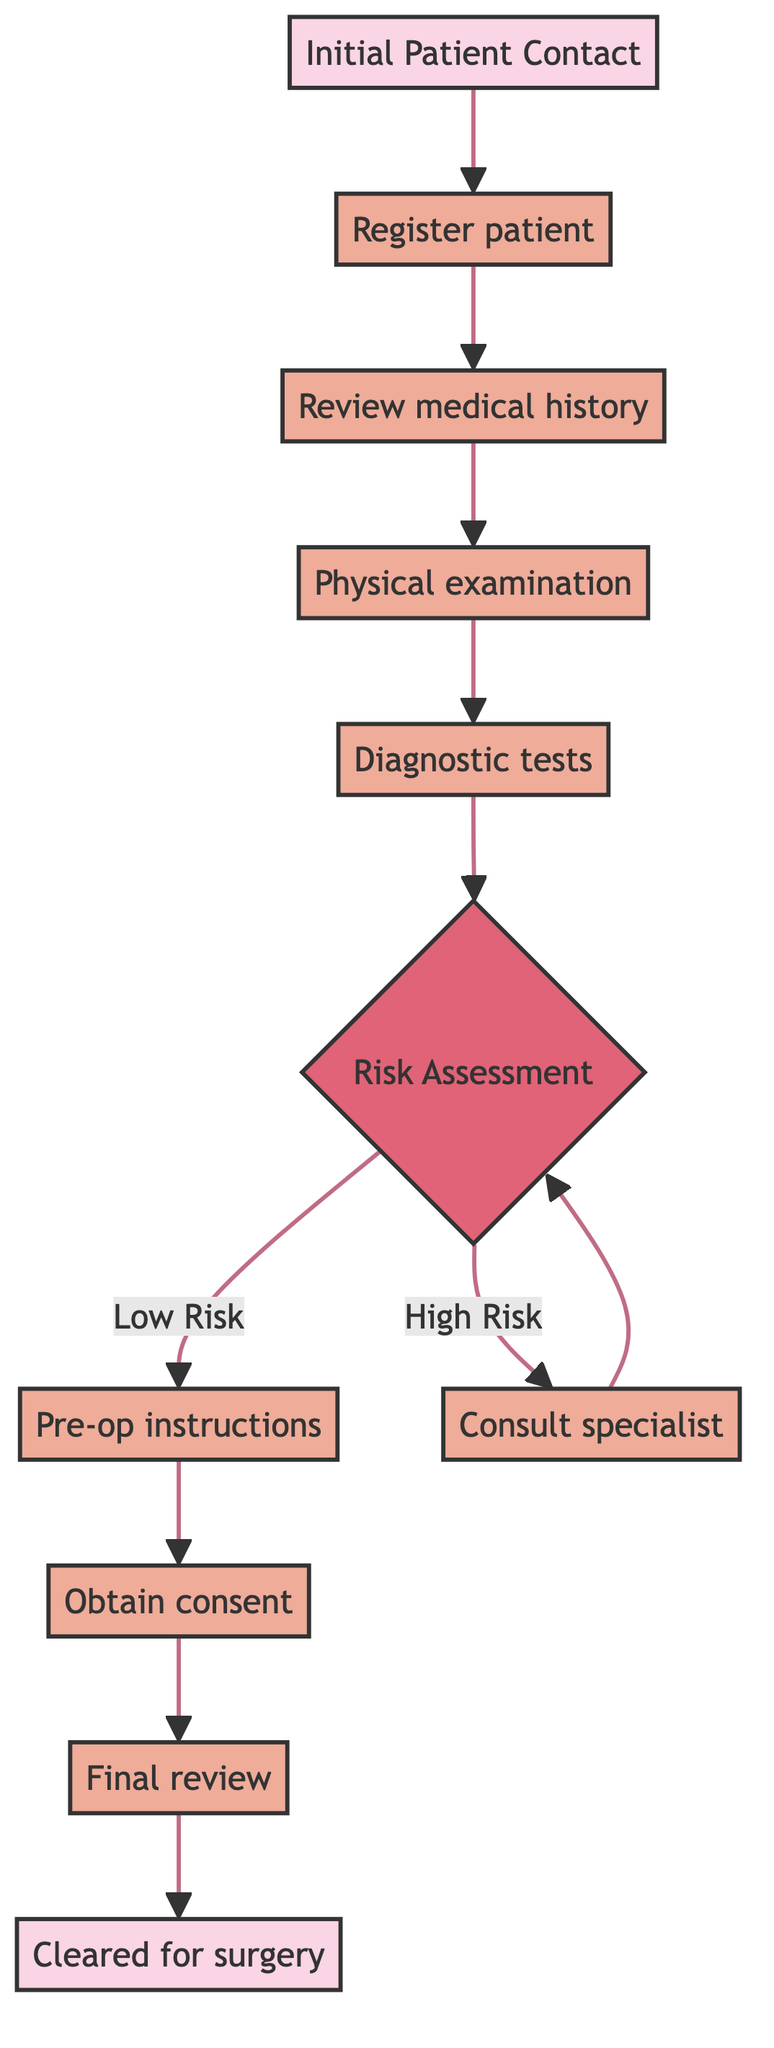What's the first step in the process? The flowchart starts with "Initial Patient Contact," which indicates the entry point of the process.
Answer: Initial Patient Contact How many decision points are in the diagram? There is one decision point labeled "Risk Assessment" in the flowchart, where the risk level is evaluated.
Answer: 1 What happens if the risk is assessed as high? If the risk is high, the next step is to consult with a specialist for further evaluation, as indicated by the arrow connecting the decision point to that process.
Answer: Consult with specialist & further evaluation What is the last step in the assessment process? The final step in the process is described as the patient being cleared for surgery, which concludes the pathway.
Answer: Patient is cleared for surgery Which step follows the physical examination? After the physical examination, the next step is to order and perform necessary pre-operative diagnostic tests, as implied by the flow of the chart.
Answer: Order and perform necessary pre-operative diagnostic tests What are the two possible outcomes of the risk assessment? The two outcomes from the risk assessment decision are "Low Risk" and "High Risk," leading to different paths based on the evaluation.
Answer: Low Risk, High Risk How many processes are involved in the flowchart? In total, there are six processes detailed in the flowchart, including registration, history review, physical examination, diagnostic tests, pre-op instructions, and consent form signature.
Answer: 6 What instruction is provided to the patient before surgery? The patient is given pre-operative guidelines and instructions before proceeding to sign the consent form.
Answer: Pre-operative guidelines and instructions 